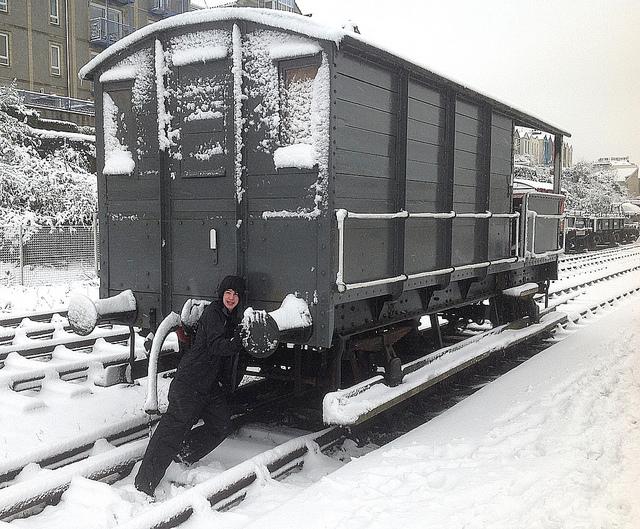Is this person pushing the train car?
Short answer required. No. What is this person leaning against?
Quick response, please. Train. What is covering the tracks?
Short answer required. Snow. 